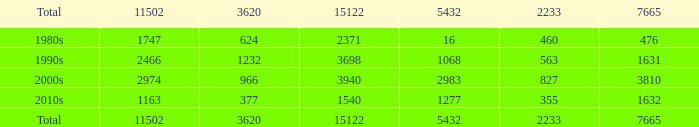What is the highest 3620 value with a 5432 of 5432 and a 15122 greater than 15122? None. 